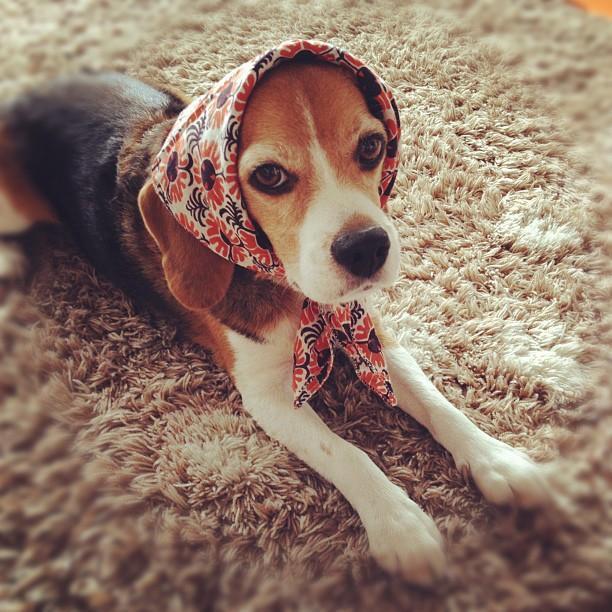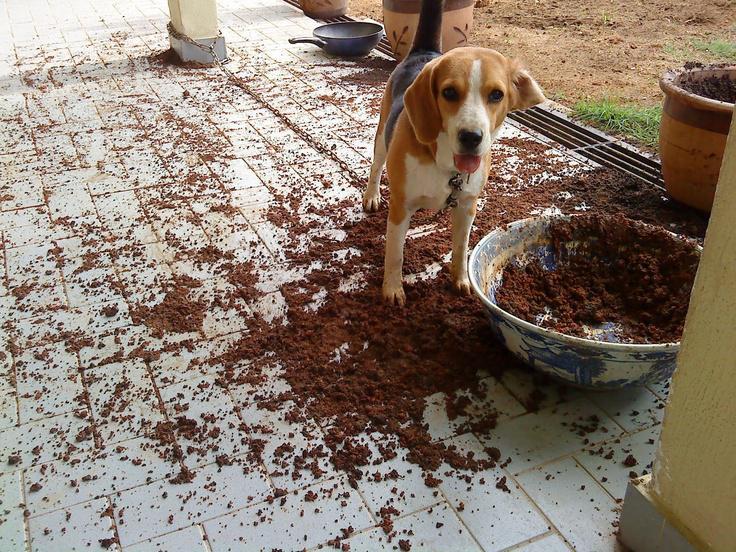The first image is the image on the left, the second image is the image on the right. For the images shown, is this caption "No image contains more than one beagle dog, and at least one dog looks directly at the camera." true? Answer yes or no. Yes. The first image is the image on the left, the second image is the image on the right. Examine the images to the left and right. Is the description "Each image shows exactly one beagle, and at least one beagle is looking at the camera." accurate? Answer yes or no. Yes. 